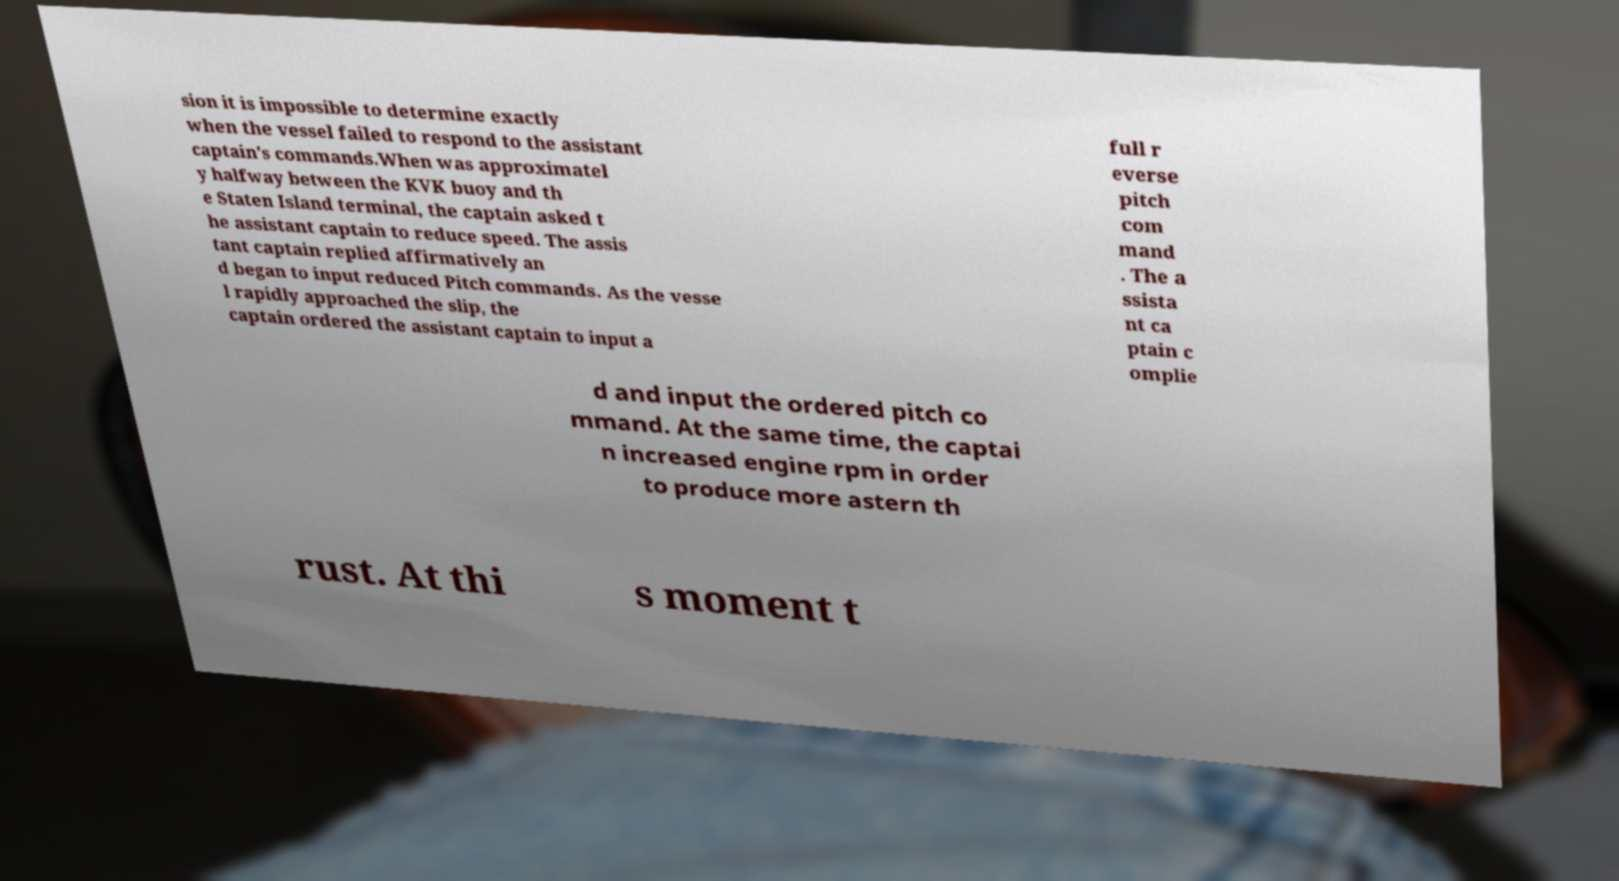There's text embedded in this image that I need extracted. Can you transcribe it verbatim? sion it is impossible to determine exactly when the vessel failed to respond to the assistant captain's commands.When was approximatel y halfway between the KVK buoy and th e Staten Island terminal, the captain asked t he assistant captain to reduce speed. The assis tant captain replied affirmatively an d began to input reduced Pitch commands. As the vesse l rapidly approached the slip, the captain ordered the assistant captain to input a full r everse pitch com mand . The a ssista nt ca ptain c omplie d and input the ordered pitch co mmand. At the same time, the captai n increased engine rpm in order to produce more astern th rust. At thi s moment t 